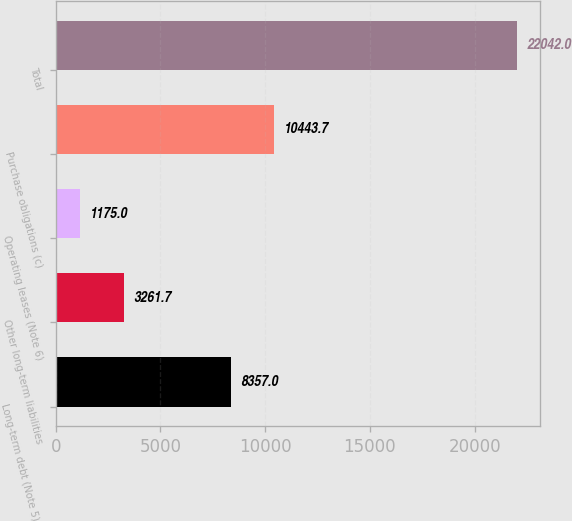Convert chart to OTSL. <chart><loc_0><loc_0><loc_500><loc_500><bar_chart><fcel>Long-term debt (Note 5) (a)<fcel>Other long-term liabilities<fcel>Operating leases (Note 6)<fcel>Purchase obligations (c)<fcel>Total<nl><fcel>8357<fcel>3261.7<fcel>1175<fcel>10443.7<fcel>22042<nl></chart> 